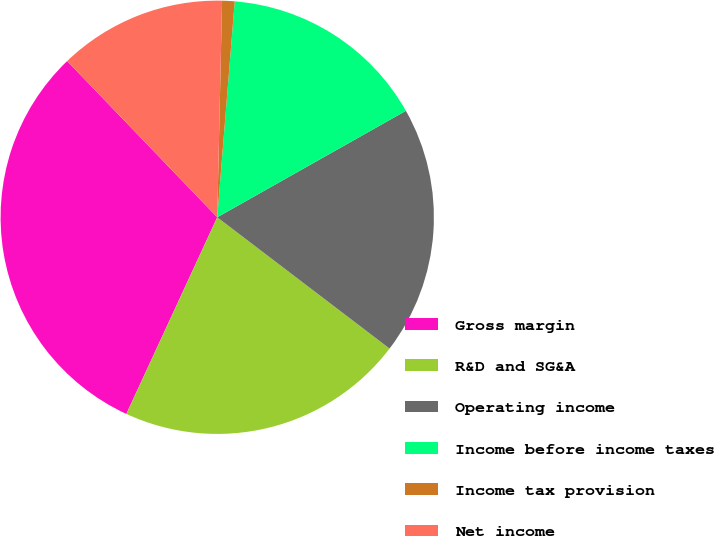<chart> <loc_0><loc_0><loc_500><loc_500><pie_chart><fcel>Gross margin<fcel>R&D and SG&A<fcel>Operating income<fcel>Income before income taxes<fcel>Income tax provision<fcel>Net income<nl><fcel>30.93%<fcel>21.53%<fcel>18.54%<fcel>15.54%<fcel>0.93%<fcel>12.54%<nl></chart> 